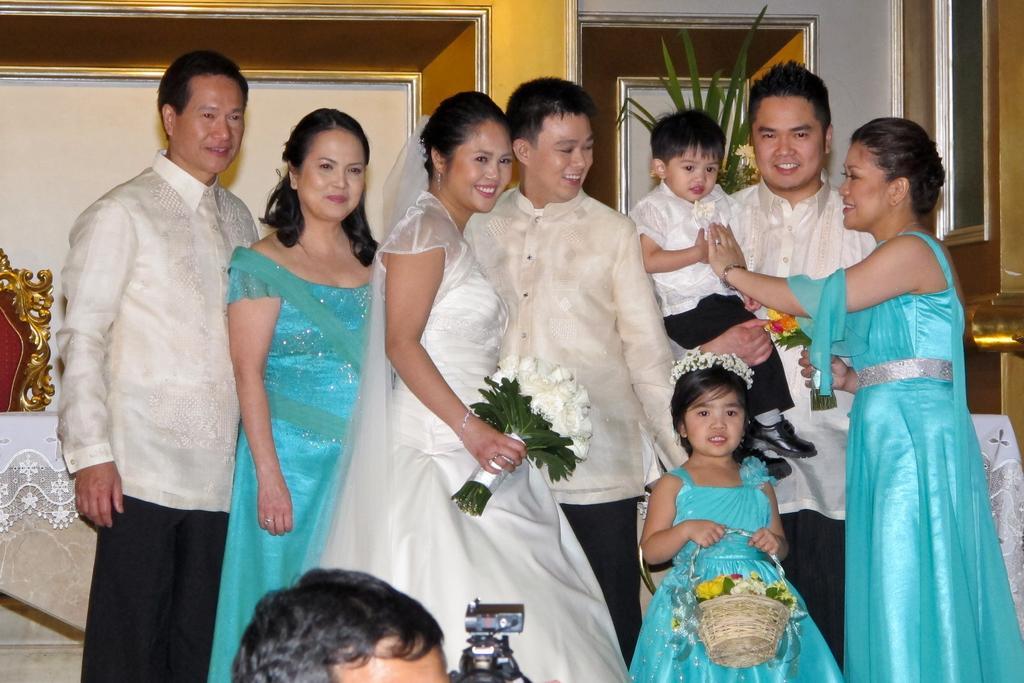Can you describe this image briefly? In this picture I see person and a camera in front and behind the person I see few people who are standing and I see most of them are smiling and I see a girl in front of them who is holding a basket in which there are flowers and in the background I see the wall and I see a plant behind these people. 